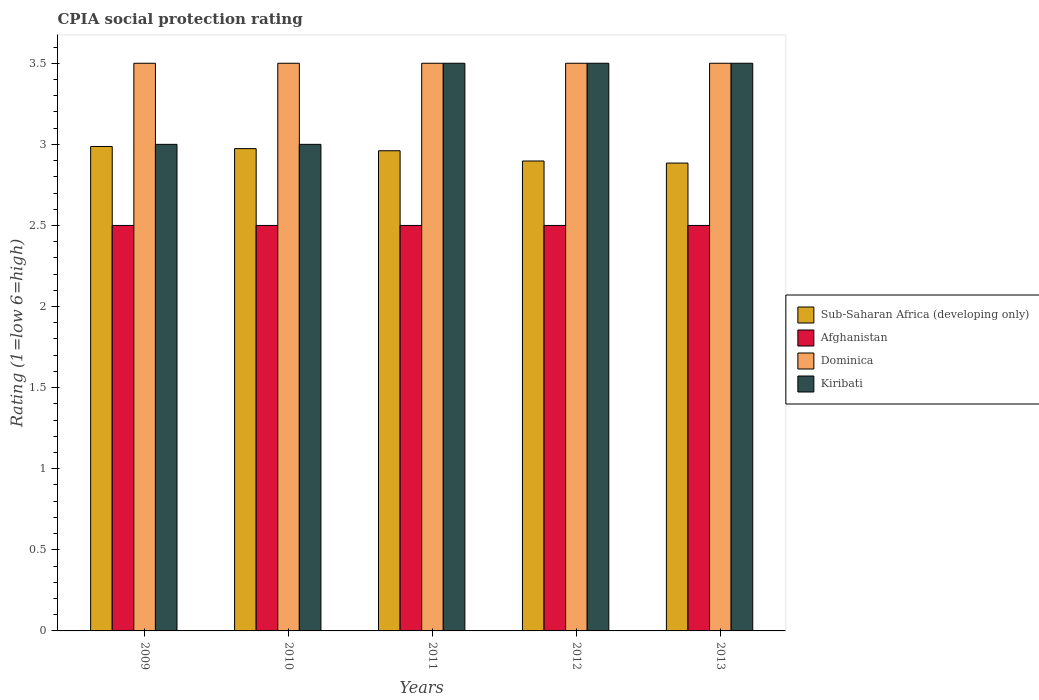How many different coloured bars are there?
Offer a terse response. 4. Are the number of bars per tick equal to the number of legend labels?
Your response must be concise. Yes. How many bars are there on the 5th tick from the right?
Give a very brief answer. 4. What is the label of the 2nd group of bars from the left?
Your response must be concise. 2010. In how many cases, is the number of bars for a given year not equal to the number of legend labels?
Provide a succinct answer. 0. What is the CPIA rating in Sub-Saharan Africa (developing only) in 2010?
Provide a succinct answer. 2.97. In which year was the CPIA rating in Kiribati maximum?
Ensure brevity in your answer.  2011. In which year was the CPIA rating in Kiribati minimum?
Provide a short and direct response. 2009. What is the total CPIA rating in Kiribati in the graph?
Your answer should be compact. 16.5. What is the difference between the CPIA rating in Dominica in 2009 and the CPIA rating in Sub-Saharan Africa (developing only) in 2012?
Your answer should be very brief. 0.6. In how many years, is the CPIA rating in Dominica greater than 1.6?
Provide a short and direct response. 5. What is the ratio of the CPIA rating in Sub-Saharan Africa (developing only) in 2010 to that in 2012?
Ensure brevity in your answer.  1.03. Is the CPIA rating in Sub-Saharan Africa (developing only) in 2011 less than that in 2013?
Keep it short and to the point. No. What is the difference between the highest and the lowest CPIA rating in Sub-Saharan Africa (developing only)?
Provide a succinct answer. 0.1. In how many years, is the CPIA rating in Dominica greater than the average CPIA rating in Dominica taken over all years?
Provide a short and direct response. 0. Is the sum of the CPIA rating in Dominica in 2011 and 2013 greater than the maximum CPIA rating in Afghanistan across all years?
Offer a very short reply. Yes. Is it the case that in every year, the sum of the CPIA rating in Dominica and CPIA rating in Sub-Saharan Africa (developing only) is greater than the sum of CPIA rating in Afghanistan and CPIA rating in Kiribati?
Your answer should be very brief. Yes. What does the 4th bar from the left in 2010 represents?
Give a very brief answer. Kiribati. What does the 3rd bar from the right in 2009 represents?
Your answer should be compact. Afghanistan. How many bars are there?
Provide a short and direct response. 20. Are all the bars in the graph horizontal?
Provide a succinct answer. No. How many years are there in the graph?
Provide a short and direct response. 5. What is the difference between two consecutive major ticks on the Y-axis?
Your answer should be very brief. 0.5. Are the values on the major ticks of Y-axis written in scientific E-notation?
Offer a terse response. No. Does the graph contain grids?
Your answer should be very brief. No. What is the title of the graph?
Provide a succinct answer. CPIA social protection rating. Does "Myanmar" appear as one of the legend labels in the graph?
Provide a short and direct response. No. What is the label or title of the Y-axis?
Give a very brief answer. Rating (1=low 6=high). What is the Rating (1=low 6=high) in Sub-Saharan Africa (developing only) in 2009?
Make the answer very short. 2.99. What is the Rating (1=low 6=high) of Sub-Saharan Africa (developing only) in 2010?
Provide a succinct answer. 2.97. What is the Rating (1=low 6=high) of Afghanistan in 2010?
Make the answer very short. 2.5. What is the Rating (1=low 6=high) in Kiribati in 2010?
Keep it short and to the point. 3. What is the Rating (1=low 6=high) of Sub-Saharan Africa (developing only) in 2011?
Offer a very short reply. 2.96. What is the Rating (1=low 6=high) of Afghanistan in 2011?
Ensure brevity in your answer.  2.5. What is the Rating (1=low 6=high) of Kiribati in 2011?
Your response must be concise. 3.5. What is the Rating (1=low 6=high) of Sub-Saharan Africa (developing only) in 2012?
Make the answer very short. 2.9. What is the Rating (1=low 6=high) in Afghanistan in 2012?
Offer a terse response. 2.5. What is the Rating (1=low 6=high) of Kiribati in 2012?
Your answer should be compact. 3.5. What is the Rating (1=low 6=high) of Sub-Saharan Africa (developing only) in 2013?
Make the answer very short. 2.88. Across all years, what is the maximum Rating (1=low 6=high) in Sub-Saharan Africa (developing only)?
Make the answer very short. 2.99. Across all years, what is the maximum Rating (1=low 6=high) of Dominica?
Your answer should be compact. 3.5. Across all years, what is the minimum Rating (1=low 6=high) in Sub-Saharan Africa (developing only)?
Offer a very short reply. 2.88. Across all years, what is the minimum Rating (1=low 6=high) in Kiribati?
Your answer should be compact. 3. What is the total Rating (1=low 6=high) in Sub-Saharan Africa (developing only) in the graph?
Your answer should be very brief. 14.7. What is the total Rating (1=low 6=high) of Kiribati in the graph?
Offer a terse response. 16.5. What is the difference between the Rating (1=low 6=high) of Sub-Saharan Africa (developing only) in 2009 and that in 2010?
Your answer should be very brief. 0.01. What is the difference between the Rating (1=low 6=high) in Afghanistan in 2009 and that in 2010?
Your answer should be very brief. 0. What is the difference between the Rating (1=low 6=high) of Sub-Saharan Africa (developing only) in 2009 and that in 2011?
Give a very brief answer. 0.03. What is the difference between the Rating (1=low 6=high) in Sub-Saharan Africa (developing only) in 2009 and that in 2012?
Your answer should be compact. 0.09. What is the difference between the Rating (1=low 6=high) in Afghanistan in 2009 and that in 2012?
Give a very brief answer. 0. What is the difference between the Rating (1=low 6=high) in Dominica in 2009 and that in 2012?
Make the answer very short. 0. What is the difference between the Rating (1=low 6=high) in Sub-Saharan Africa (developing only) in 2009 and that in 2013?
Give a very brief answer. 0.1. What is the difference between the Rating (1=low 6=high) of Afghanistan in 2009 and that in 2013?
Ensure brevity in your answer.  0. What is the difference between the Rating (1=low 6=high) in Dominica in 2009 and that in 2013?
Give a very brief answer. 0. What is the difference between the Rating (1=low 6=high) of Sub-Saharan Africa (developing only) in 2010 and that in 2011?
Provide a short and direct response. 0.01. What is the difference between the Rating (1=low 6=high) of Afghanistan in 2010 and that in 2011?
Your answer should be very brief. 0. What is the difference between the Rating (1=low 6=high) of Sub-Saharan Africa (developing only) in 2010 and that in 2012?
Your answer should be compact. 0.08. What is the difference between the Rating (1=low 6=high) in Sub-Saharan Africa (developing only) in 2010 and that in 2013?
Give a very brief answer. 0.09. What is the difference between the Rating (1=low 6=high) in Afghanistan in 2010 and that in 2013?
Your response must be concise. 0. What is the difference between the Rating (1=low 6=high) in Sub-Saharan Africa (developing only) in 2011 and that in 2012?
Make the answer very short. 0.06. What is the difference between the Rating (1=low 6=high) of Afghanistan in 2011 and that in 2012?
Your answer should be very brief. 0. What is the difference between the Rating (1=low 6=high) of Kiribati in 2011 and that in 2012?
Your answer should be very brief. 0. What is the difference between the Rating (1=low 6=high) of Sub-Saharan Africa (developing only) in 2011 and that in 2013?
Your answer should be very brief. 0.08. What is the difference between the Rating (1=low 6=high) in Kiribati in 2011 and that in 2013?
Provide a succinct answer. 0. What is the difference between the Rating (1=low 6=high) of Sub-Saharan Africa (developing only) in 2012 and that in 2013?
Ensure brevity in your answer.  0.01. What is the difference between the Rating (1=low 6=high) of Afghanistan in 2012 and that in 2013?
Ensure brevity in your answer.  0. What is the difference between the Rating (1=low 6=high) of Dominica in 2012 and that in 2013?
Your response must be concise. 0. What is the difference between the Rating (1=low 6=high) of Sub-Saharan Africa (developing only) in 2009 and the Rating (1=low 6=high) of Afghanistan in 2010?
Provide a short and direct response. 0.49. What is the difference between the Rating (1=low 6=high) of Sub-Saharan Africa (developing only) in 2009 and the Rating (1=low 6=high) of Dominica in 2010?
Keep it short and to the point. -0.51. What is the difference between the Rating (1=low 6=high) in Sub-Saharan Africa (developing only) in 2009 and the Rating (1=low 6=high) in Kiribati in 2010?
Make the answer very short. -0.01. What is the difference between the Rating (1=low 6=high) in Afghanistan in 2009 and the Rating (1=low 6=high) in Kiribati in 2010?
Provide a succinct answer. -0.5. What is the difference between the Rating (1=low 6=high) in Sub-Saharan Africa (developing only) in 2009 and the Rating (1=low 6=high) in Afghanistan in 2011?
Provide a succinct answer. 0.49. What is the difference between the Rating (1=low 6=high) of Sub-Saharan Africa (developing only) in 2009 and the Rating (1=low 6=high) of Dominica in 2011?
Offer a terse response. -0.51. What is the difference between the Rating (1=low 6=high) in Sub-Saharan Africa (developing only) in 2009 and the Rating (1=low 6=high) in Kiribati in 2011?
Provide a short and direct response. -0.51. What is the difference between the Rating (1=low 6=high) of Afghanistan in 2009 and the Rating (1=low 6=high) of Dominica in 2011?
Give a very brief answer. -1. What is the difference between the Rating (1=low 6=high) in Sub-Saharan Africa (developing only) in 2009 and the Rating (1=low 6=high) in Afghanistan in 2012?
Make the answer very short. 0.49. What is the difference between the Rating (1=low 6=high) of Sub-Saharan Africa (developing only) in 2009 and the Rating (1=low 6=high) of Dominica in 2012?
Ensure brevity in your answer.  -0.51. What is the difference between the Rating (1=low 6=high) in Sub-Saharan Africa (developing only) in 2009 and the Rating (1=low 6=high) in Kiribati in 2012?
Offer a very short reply. -0.51. What is the difference between the Rating (1=low 6=high) in Afghanistan in 2009 and the Rating (1=low 6=high) in Dominica in 2012?
Ensure brevity in your answer.  -1. What is the difference between the Rating (1=low 6=high) in Afghanistan in 2009 and the Rating (1=low 6=high) in Kiribati in 2012?
Your answer should be very brief. -1. What is the difference between the Rating (1=low 6=high) in Dominica in 2009 and the Rating (1=low 6=high) in Kiribati in 2012?
Your answer should be very brief. 0. What is the difference between the Rating (1=low 6=high) in Sub-Saharan Africa (developing only) in 2009 and the Rating (1=low 6=high) in Afghanistan in 2013?
Offer a terse response. 0.49. What is the difference between the Rating (1=low 6=high) of Sub-Saharan Africa (developing only) in 2009 and the Rating (1=low 6=high) of Dominica in 2013?
Offer a terse response. -0.51. What is the difference between the Rating (1=low 6=high) of Sub-Saharan Africa (developing only) in 2009 and the Rating (1=low 6=high) of Kiribati in 2013?
Your response must be concise. -0.51. What is the difference between the Rating (1=low 6=high) of Afghanistan in 2009 and the Rating (1=low 6=high) of Dominica in 2013?
Provide a short and direct response. -1. What is the difference between the Rating (1=low 6=high) of Sub-Saharan Africa (developing only) in 2010 and the Rating (1=low 6=high) of Afghanistan in 2011?
Provide a succinct answer. 0.47. What is the difference between the Rating (1=low 6=high) in Sub-Saharan Africa (developing only) in 2010 and the Rating (1=low 6=high) in Dominica in 2011?
Keep it short and to the point. -0.53. What is the difference between the Rating (1=low 6=high) of Sub-Saharan Africa (developing only) in 2010 and the Rating (1=low 6=high) of Kiribati in 2011?
Provide a succinct answer. -0.53. What is the difference between the Rating (1=low 6=high) of Sub-Saharan Africa (developing only) in 2010 and the Rating (1=low 6=high) of Afghanistan in 2012?
Give a very brief answer. 0.47. What is the difference between the Rating (1=low 6=high) of Sub-Saharan Africa (developing only) in 2010 and the Rating (1=low 6=high) of Dominica in 2012?
Keep it short and to the point. -0.53. What is the difference between the Rating (1=low 6=high) of Sub-Saharan Africa (developing only) in 2010 and the Rating (1=low 6=high) of Kiribati in 2012?
Your response must be concise. -0.53. What is the difference between the Rating (1=low 6=high) in Afghanistan in 2010 and the Rating (1=low 6=high) in Dominica in 2012?
Provide a short and direct response. -1. What is the difference between the Rating (1=low 6=high) of Afghanistan in 2010 and the Rating (1=low 6=high) of Kiribati in 2012?
Keep it short and to the point. -1. What is the difference between the Rating (1=low 6=high) of Dominica in 2010 and the Rating (1=low 6=high) of Kiribati in 2012?
Offer a terse response. 0. What is the difference between the Rating (1=low 6=high) in Sub-Saharan Africa (developing only) in 2010 and the Rating (1=low 6=high) in Afghanistan in 2013?
Your answer should be very brief. 0.47. What is the difference between the Rating (1=low 6=high) in Sub-Saharan Africa (developing only) in 2010 and the Rating (1=low 6=high) in Dominica in 2013?
Your answer should be compact. -0.53. What is the difference between the Rating (1=low 6=high) in Sub-Saharan Africa (developing only) in 2010 and the Rating (1=low 6=high) in Kiribati in 2013?
Provide a short and direct response. -0.53. What is the difference between the Rating (1=low 6=high) in Afghanistan in 2010 and the Rating (1=low 6=high) in Kiribati in 2013?
Your answer should be compact. -1. What is the difference between the Rating (1=low 6=high) in Dominica in 2010 and the Rating (1=low 6=high) in Kiribati in 2013?
Give a very brief answer. 0. What is the difference between the Rating (1=low 6=high) of Sub-Saharan Africa (developing only) in 2011 and the Rating (1=low 6=high) of Afghanistan in 2012?
Your answer should be compact. 0.46. What is the difference between the Rating (1=low 6=high) of Sub-Saharan Africa (developing only) in 2011 and the Rating (1=low 6=high) of Dominica in 2012?
Offer a very short reply. -0.54. What is the difference between the Rating (1=low 6=high) of Sub-Saharan Africa (developing only) in 2011 and the Rating (1=low 6=high) of Kiribati in 2012?
Ensure brevity in your answer.  -0.54. What is the difference between the Rating (1=low 6=high) in Afghanistan in 2011 and the Rating (1=low 6=high) in Dominica in 2012?
Offer a terse response. -1. What is the difference between the Rating (1=low 6=high) of Afghanistan in 2011 and the Rating (1=low 6=high) of Kiribati in 2012?
Ensure brevity in your answer.  -1. What is the difference between the Rating (1=low 6=high) in Dominica in 2011 and the Rating (1=low 6=high) in Kiribati in 2012?
Keep it short and to the point. 0. What is the difference between the Rating (1=low 6=high) in Sub-Saharan Africa (developing only) in 2011 and the Rating (1=low 6=high) in Afghanistan in 2013?
Provide a succinct answer. 0.46. What is the difference between the Rating (1=low 6=high) in Sub-Saharan Africa (developing only) in 2011 and the Rating (1=low 6=high) in Dominica in 2013?
Offer a very short reply. -0.54. What is the difference between the Rating (1=low 6=high) of Sub-Saharan Africa (developing only) in 2011 and the Rating (1=low 6=high) of Kiribati in 2013?
Offer a very short reply. -0.54. What is the difference between the Rating (1=low 6=high) in Afghanistan in 2011 and the Rating (1=low 6=high) in Kiribati in 2013?
Offer a terse response. -1. What is the difference between the Rating (1=low 6=high) in Sub-Saharan Africa (developing only) in 2012 and the Rating (1=low 6=high) in Afghanistan in 2013?
Keep it short and to the point. 0.4. What is the difference between the Rating (1=low 6=high) in Sub-Saharan Africa (developing only) in 2012 and the Rating (1=low 6=high) in Dominica in 2013?
Offer a terse response. -0.6. What is the difference between the Rating (1=low 6=high) of Sub-Saharan Africa (developing only) in 2012 and the Rating (1=low 6=high) of Kiribati in 2013?
Give a very brief answer. -0.6. What is the difference between the Rating (1=low 6=high) of Afghanistan in 2012 and the Rating (1=low 6=high) of Dominica in 2013?
Offer a terse response. -1. What is the difference between the Rating (1=low 6=high) of Dominica in 2012 and the Rating (1=low 6=high) of Kiribati in 2013?
Your answer should be compact. 0. What is the average Rating (1=low 6=high) in Sub-Saharan Africa (developing only) per year?
Provide a succinct answer. 2.94. What is the average Rating (1=low 6=high) in Dominica per year?
Provide a succinct answer. 3.5. In the year 2009, what is the difference between the Rating (1=low 6=high) of Sub-Saharan Africa (developing only) and Rating (1=low 6=high) of Afghanistan?
Your response must be concise. 0.49. In the year 2009, what is the difference between the Rating (1=low 6=high) of Sub-Saharan Africa (developing only) and Rating (1=low 6=high) of Dominica?
Keep it short and to the point. -0.51. In the year 2009, what is the difference between the Rating (1=low 6=high) of Sub-Saharan Africa (developing only) and Rating (1=low 6=high) of Kiribati?
Keep it short and to the point. -0.01. In the year 2009, what is the difference between the Rating (1=low 6=high) in Afghanistan and Rating (1=low 6=high) in Dominica?
Offer a terse response. -1. In the year 2010, what is the difference between the Rating (1=low 6=high) of Sub-Saharan Africa (developing only) and Rating (1=low 6=high) of Afghanistan?
Your answer should be very brief. 0.47. In the year 2010, what is the difference between the Rating (1=low 6=high) of Sub-Saharan Africa (developing only) and Rating (1=low 6=high) of Dominica?
Offer a very short reply. -0.53. In the year 2010, what is the difference between the Rating (1=low 6=high) of Sub-Saharan Africa (developing only) and Rating (1=low 6=high) of Kiribati?
Your response must be concise. -0.03. In the year 2010, what is the difference between the Rating (1=low 6=high) in Dominica and Rating (1=low 6=high) in Kiribati?
Your response must be concise. 0.5. In the year 2011, what is the difference between the Rating (1=low 6=high) of Sub-Saharan Africa (developing only) and Rating (1=low 6=high) of Afghanistan?
Give a very brief answer. 0.46. In the year 2011, what is the difference between the Rating (1=low 6=high) of Sub-Saharan Africa (developing only) and Rating (1=low 6=high) of Dominica?
Provide a succinct answer. -0.54. In the year 2011, what is the difference between the Rating (1=low 6=high) of Sub-Saharan Africa (developing only) and Rating (1=low 6=high) of Kiribati?
Keep it short and to the point. -0.54. In the year 2011, what is the difference between the Rating (1=low 6=high) of Afghanistan and Rating (1=low 6=high) of Kiribati?
Provide a short and direct response. -1. In the year 2012, what is the difference between the Rating (1=low 6=high) in Sub-Saharan Africa (developing only) and Rating (1=low 6=high) in Afghanistan?
Ensure brevity in your answer.  0.4. In the year 2012, what is the difference between the Rating (1=low 6=high) in Sub-Saharan Africa (developing only) and Rating (1=low 6=high) in Dominica?
Your answer should be very brief. -0.6. In the year 2012, what is the difference between the Rating (1=low 6=high) in Sub-Saharan Africa (developing only) and Rating (1=low 6=high) in Kiribati?
Provide a short and direct response. -0.6. In the year 2012, what is the difference between the Rating (1=low 6=high) in Afghanistan and Rating (1=low 6=high) in Dominica?
Ensure brevity in your answer.  -1. In the year 2013, what is the difference between the Rating (1=low 6=high) in Sub-Saharan Africa (developing only) and Rating (1=low 6=high) in Afghanistan?
Keep it short and to the point. 0.38. In the year 2013, what is the difference between the Rating (1=low 6=high) in Sub-Saharan Africa (developing only) and Rating (1=low 6=high) in Dominica?
Keep it short and to the point. -0.62. In the year 2013, what is the difference between the Rating (1=low 6=high) of Sub-Saharan Africa (developing only) and Rating (1=low 6=high) of Kiribati?
Give a very brief answer. -0.62. In the year 2013, what is the difference between the Rating (1=low 6=high) of Afghanistan and Rating (1=low 6=high) of Kiribati?
Your answer should be compact. -1. What is the ratio of the Rating (1=low 6=high) in Afghanistan in 2009 to that in 2010?
Your answer should be very brief. 1. What is the ratio of the Rating (1=low 6=high) in Dominica in 2009 to that in 2010?
Offer a terse response. 1. What is the ratio of the Rating (1=low 6=high) of Kiribati in 2009 to that in 2010?
Make the answer very short. 1. What is the ratio of the Rating (1=low 6=high) in Sub-Saharan Africa (developing only) in 2009 to that in 2011?
Your answer should be very brief. 1.01. What is the ratio of the Rating (1=low 6=high) in Sub-Saharan Africa (developing only) in 2009 to that in 2012?
Make the answer very short. 1.03. What is the ratio of the Rating (1=low 6=high) of Sub-Saharan Africa (developing only) in 2009 to that in 2013?
Keep it short and to the point. 1.04. What is the ratio of the Rating (1=low 6=high) of Dominica in 2009 to that in 2013?
Offer a very short reply. 1. What is the ratio of the Rating (1=low 6=high) of Sub-Saharan Africa (developing only) in 2010 to that in 2012?
Offer a very short reply. 1.03. What is the ratio of the Rating (1=low 6=high) of Dominica in 2010 to that in 2012?
Your response must be concise. 1. What is the ratio of the Rating (1=low 6=high) of Sub-Saharan Africa (developing only) in 2010 to that in 2013?
Keep it short and to the point. 1.03. What is the ratio of the Rating (1=low 6=high) in Dominica in 2010 to that in 2013?
Your response must be concise. 1. What is the ratio of the Rating (1=low 6=high) in Kiribati in 2010 to that in 2013?
Provide a short and direct response. 0.86. What is the ratio of the Rating (1=low 6=high) in Sub-Saharan Africa (developing only) in 2011 to that in 2012?
Your response must be concise. 1.02. What is the ratio of the Rating (1=low 6=high) of Kiribati in 2011 to that in 2012?
Make the answer very short. 1. What is the ratio of the Rating (1=low 6=high) of Sub-Saharan Africa (developing only) in 2011 to that in 2013?
Offer a terse response. 1.03. What is the ratio of the Rating (1=low 6=high) in Dominica in 2011 to that in 2013?
Ensure brevity in your answer.  1. What is the ratio of the Rating (1=low 6=high) of Dominica in 2012 to that in 2013?
Your answer should be compact. 1. What is the difference between the highest and the second highest Rating (1=low 6=high) in Sub-Saharan Africa (developing only)?
Ensure brevity in your answer.  0.01. What is the difference between the highest and the lowest Rating (1=low 6=high) in Sub-Saharan Africa (developing only)?
Ensure brevity in your answer.  0.1. What is the difference between the highest and the lowest Rating (1=low 6=high) of Afghanistan?
Your answer should be compact. 0. What is the difference between the highest and the lowest Rating (1=low 6=high) of Dominica?
Give a very brief answer. 0. What is the difference between the highest and the lowest Rating (1=low 6=high) in Kiribati?
Give a very brief answer. 0.5. 